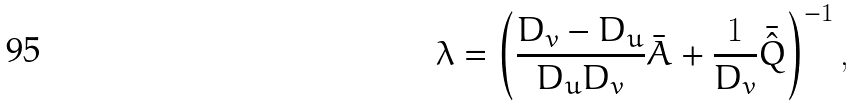Convert formula to latex. <formula><loc_0><loc_0><loc_500><loc_500>\lambda = \left ( \frac { D _ { v } - D _ { u } } { D _ { u } D _ { v } } \bar { A } + \frac { 1 } { D _ { v } } \bar { \hat { Q } } \right ) ^ { - 1 } ,</formula> 